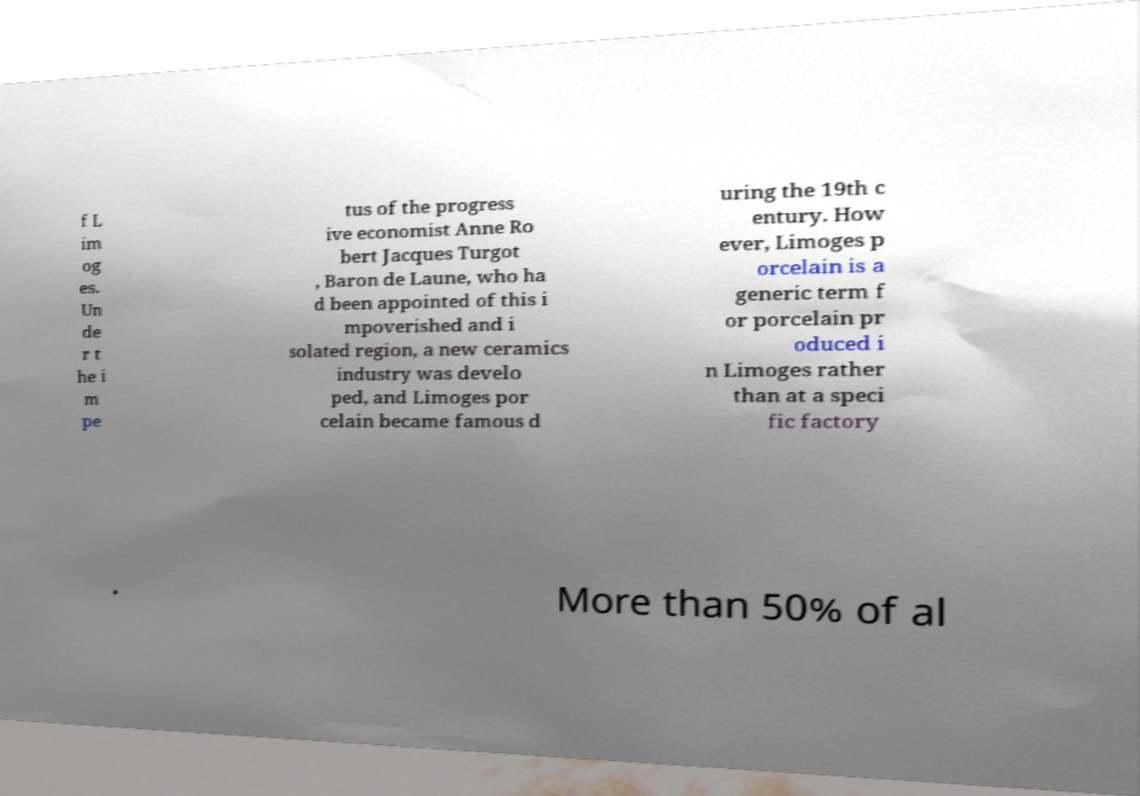There's text embedded in this image that I need extracted. Can you transcribe it verbatim? f L im og es. Un de r t he i m pe tus of the progress ive economist Anne Ro bert Jacques Turgot , Baron de Laune, who ha d been appointed of this i mpoverished and i solated region, a new ceramics industry was develo ped, and Limoges por celain became famous d uring the 19th c entury. How ever, Limoges p orcelain is a generic term f or porcelain pr oduced i n Limoges rather than at a speci fic factory . More than 50% of al 